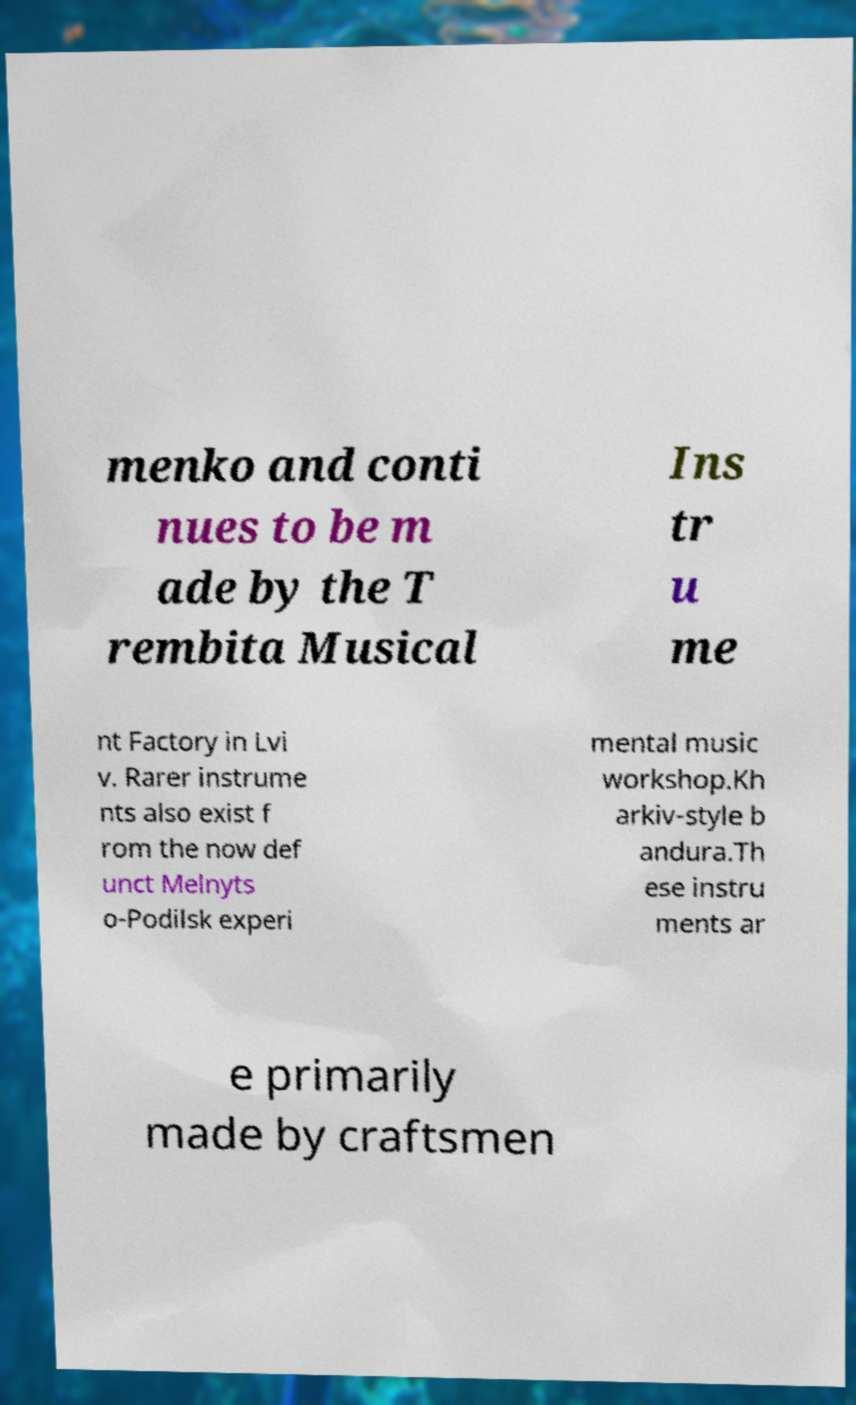Can you read and provide the text displayed in the image?This photo seems to have some interesting text. Can you extract and type it out for me? menko and conti nues to be m ade by the T rembita Musical Ins tr u me nt Factory in Lvi v. Rarer instrume nts also exist f rom the now def unct Melnyts o-Podilsk experi mental music workshop.Kh arkiv-style b andura.Th ese instru ments ar e primarily made by craftsmen 